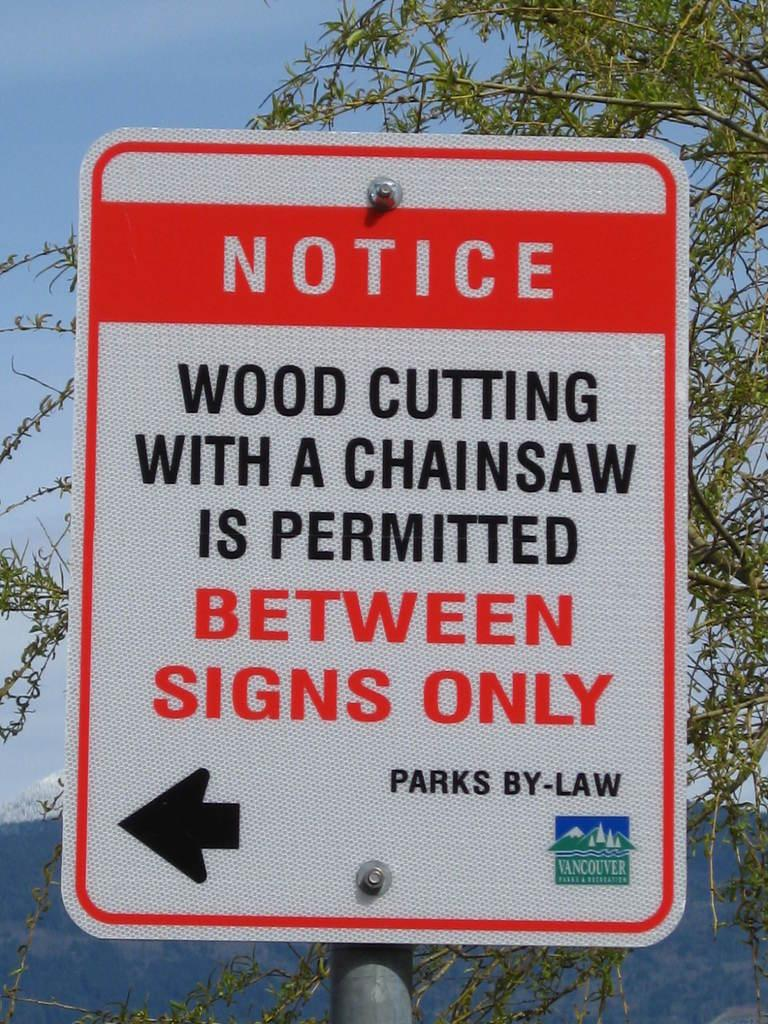<image>
Render a clear and concise summary of the photo. A sign posted in Vancouver that says NOTICE Wood Cutting with a Chainsaw is Permitted between signs only 